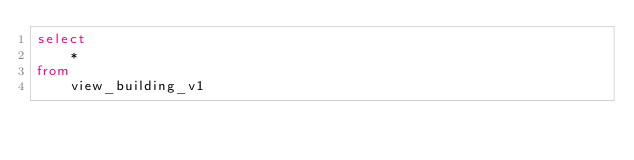Convert code to text. <code><loc_0><loc_0><loc_500><loc_500><_SQL_>select
    *
from
    view_building_v1</code> 